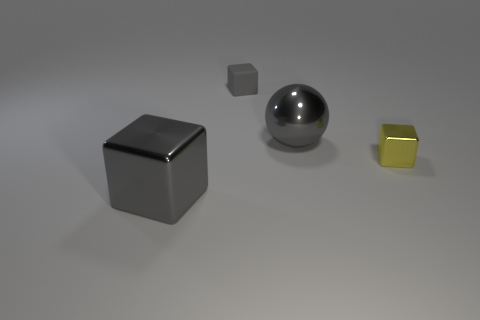Add 4 big gray cubes. How many objects exist? 8 Subtract all balls. How many objects are left? 3 Subtract 2 gray blocks. How many objects are left? 2 Subtract all tiny metal cubes. Subtract all large gray spheres. How many objects are left? 2 Add 1 rubber cubes. How many rubber cubes are left? 2 Add 1 green matte blocks. How many green matte blocks exist? 1 